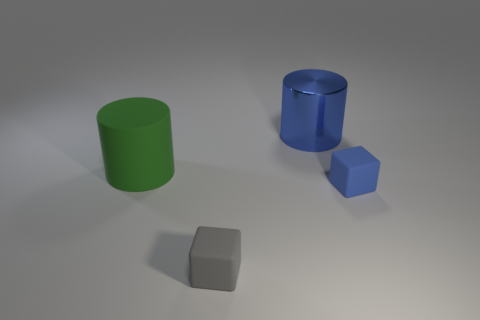Does the blue object that is in front of the big blue cylinder have the same shape as the small gray rubber thing?
Keep it short and to the point. Yes. There is a cube that is to the left of the blue block; what is it made of?
Your answer should be compact. Rubber. What number of blue objects are the same shape as the gray thing?
Your response must be concise. 1. There is a large thing that is to the right of the large thing left of the gray rubber cube; what is it made of?
Give a very brief answer. Metal. What shape is the rubber thing that is the same color as the big metallic object?
Your answer should be very brief. Cube. Are there any big purple objects made of the same material as the blue cylinder?
Make the answer very short. No. The large green rubber object is what shape?
Ensure brevity in your answer.  Cylinder. What number of large green shiny blocks are there?
Keep it short and to the point. 0. There is a tiny block that is to the left of the cylinder behind the large green cylinder; what is its color?
Provide a short and direct response. Gray. What is the color of the other matte thing that is the same size as the blue matte thing?
Your answer should be very brief. Gray. 